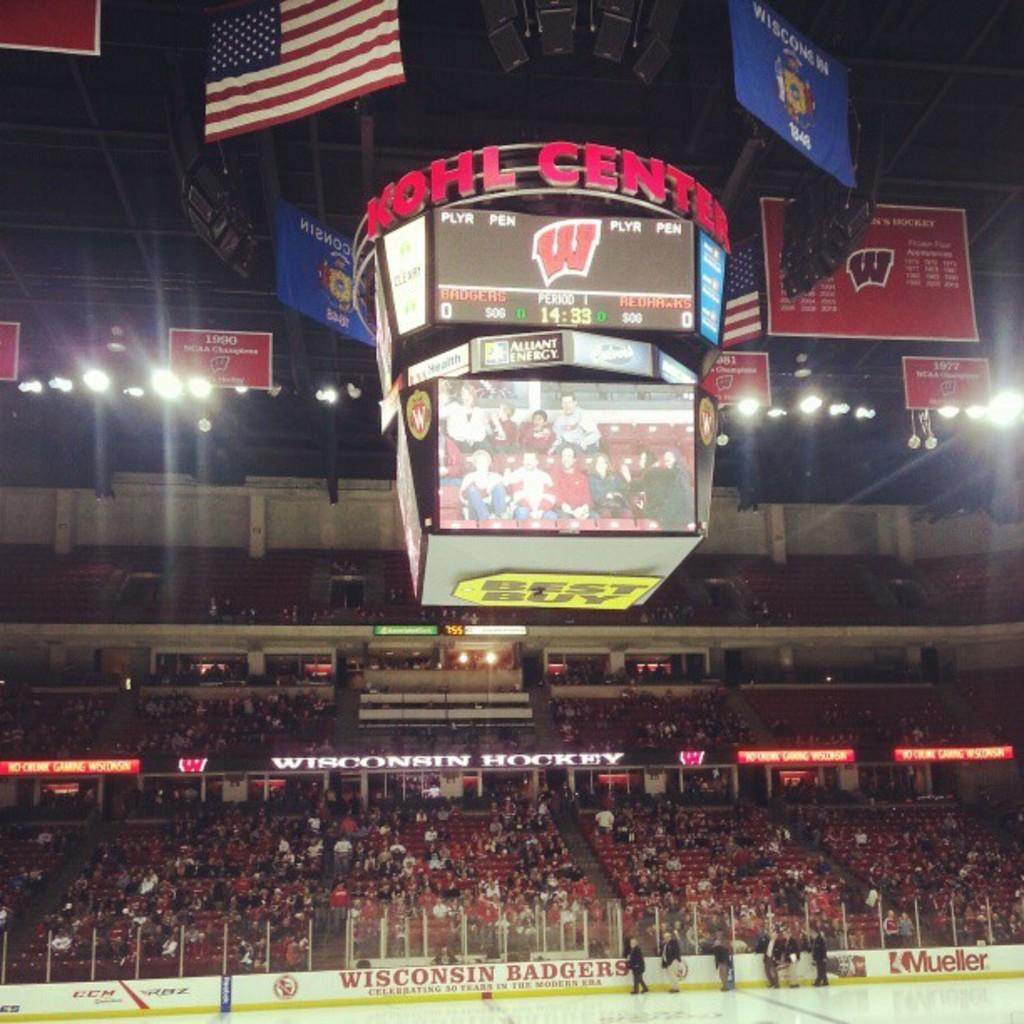Provide a one-sentence caption for the provided image. a Wiscon Badgers advertisement at the Kohl Center. 